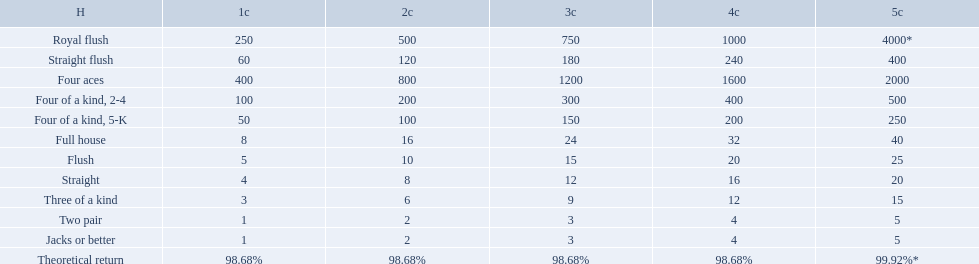What are the hands in super aces? Royal flush, Straight flush, Four aces, Four of a kind, 2-4, Four of a kind, 5-K, Full house, Flush, Straight, Three of a kind, Two pair, Jacks or better. What hand gives the highest credits? Royal flush. Which hand is lower than straight flush? Four aces. Which hand is lower than four aces? Four of a kind, 2-4. Which hand is higher out of straight and flush? Flush. What are each of the hands? Royal flush, Straight flush, Four aces, Four of a kind, 2-4, Four of a kind, 5-K, Full house, Flush, Straight, Three of a kind, Two pair, Jacks or better, Theoretical return. Which hand ranks higher between straights and flushes? Flush. 